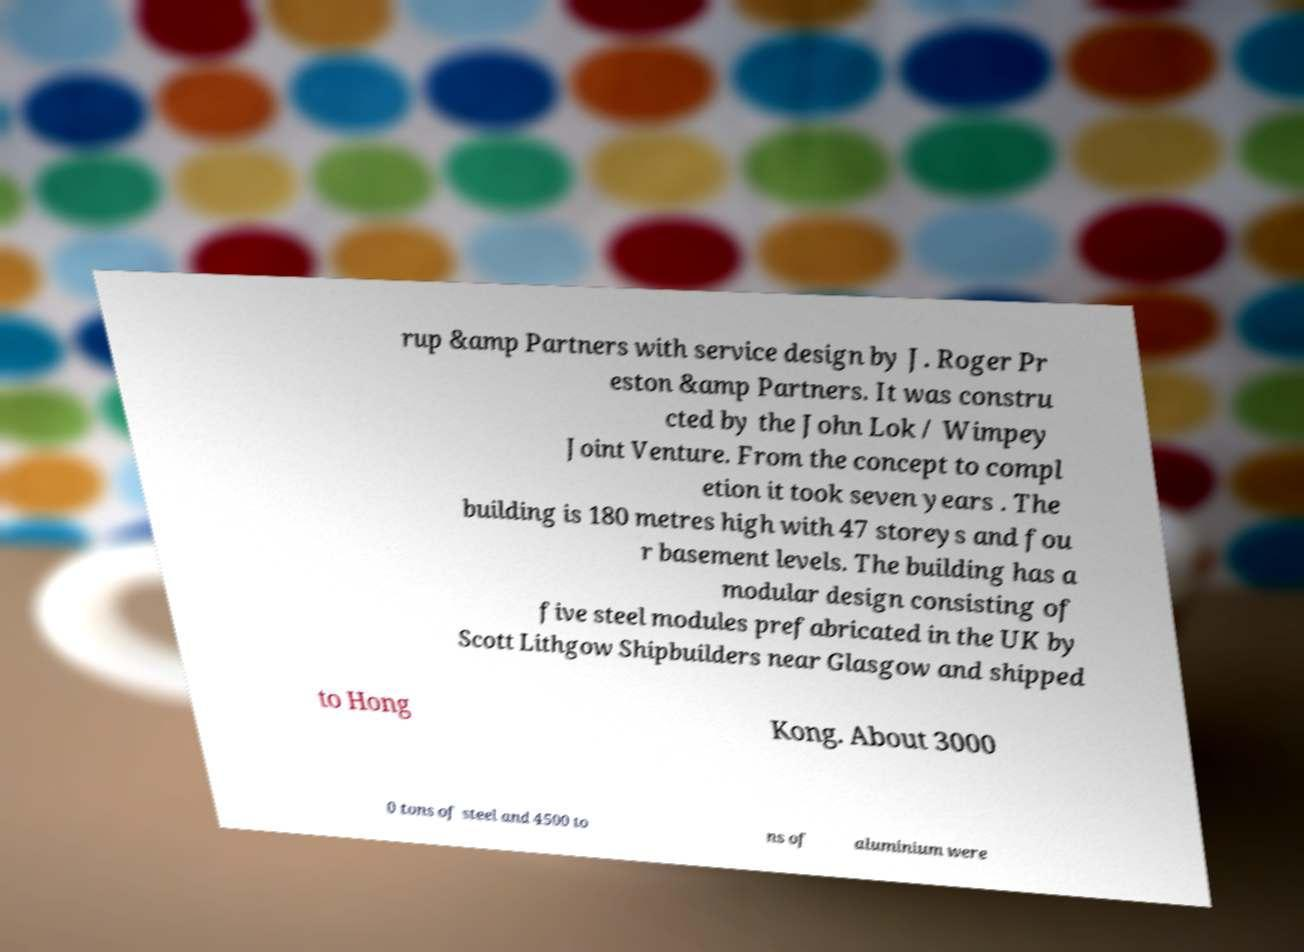Can you accurately transcribe the text from the provided image for me? rup &amp Partners with service design by J. Roger Pr eston &amp Partners. It was constru cted by the John Lok / Wimpey Joint Venture. From the concept to compl etion it took seven years . The building is 180 metres high with 47 storeys and fou r basement levels. The building has a modular design consisting of five steel modules prefabricated in the UK by Scott Lithgow Shipbuilders near Glasgow and shipped to Hong Kong. About 3000 0 tons of steel and 4500 to ns of aluminium were 